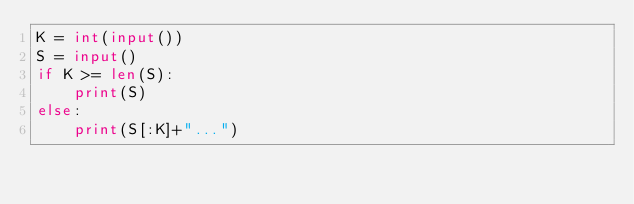Convert code to text. <code><loc_0><loc_0><loc_500><loc_500><_Python_>K = int(input())
S = input()
if K >= len(S):
    print(S)
else:
    print(S[:K]+"...")</code> 